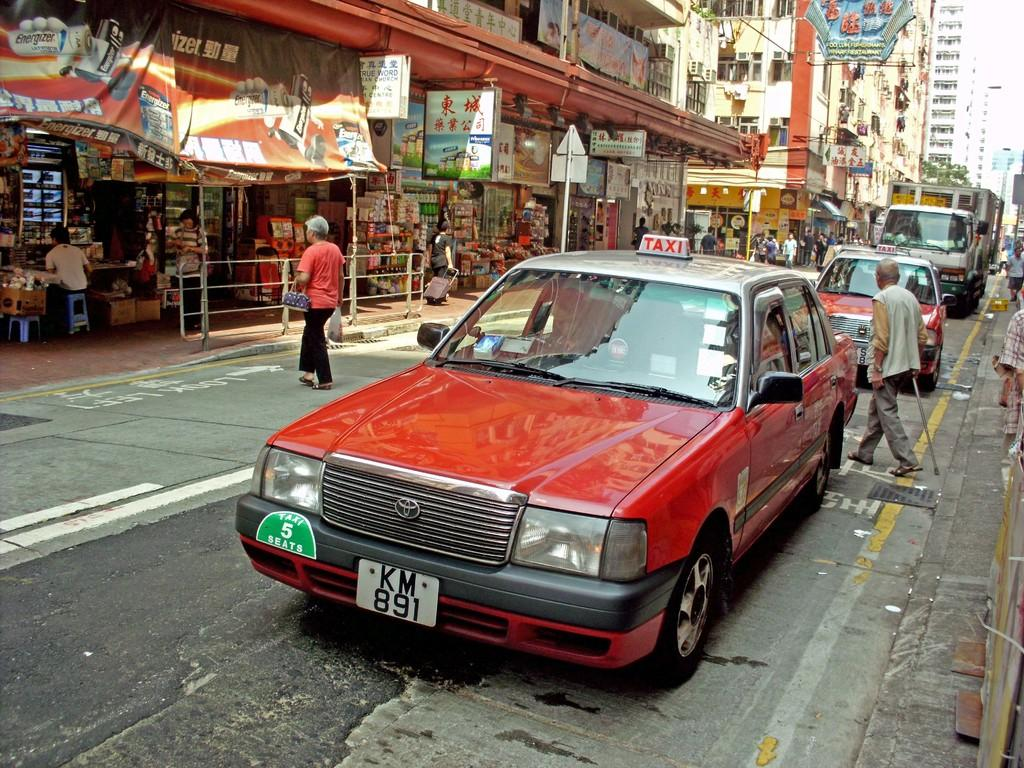<image>
Write a terse but informative summary of the picture. A red car with license plate KM 891 is parked on a busy street in front of shops. 